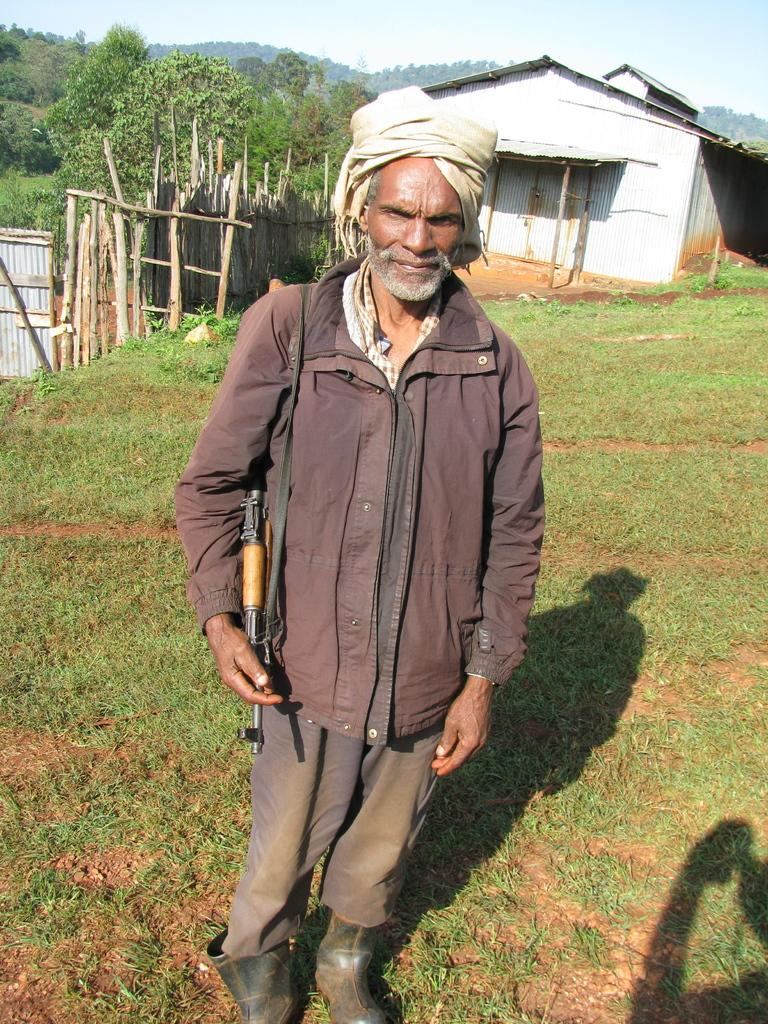What is the man in the image doing? The man is standing in the image and holding a gun. What is the ground surface like in the image? There is grass on the ground in the image. What can be seen in the background of the image? There is a house and trees visible in the image. What is the condition of the sky in the image? The sky is cloudy in the image. What type of board is the man using to fold the trees in the image? There is no board or folding activity present in the image. 